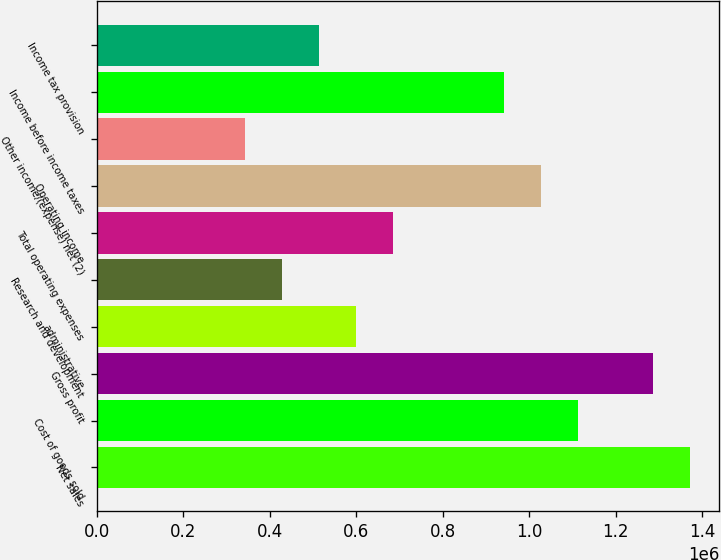Convert chart. <chart><loc_0><loc_0><loc_500><loc_500><bar_chart><fcel>Net sales<fcel>Cost of goods sold<fcel>Gross profit<fcel>administrative<fcel>Research and development<fcel>Total operating expenses<fcel>Operating income<fcel>Other income/(expense) net (2)<fcel>Income before income taxes<fcel>Income tax provision<nl><fcel>1.37111e+06<fcel>1.11403e+06<fcel>1.28542e+06<fcel>599862<fcel>428473<fcel>685556<fcel>1.02833e+06<fcel>342778<fcel>942639<fcel>514167<nl></chart> 